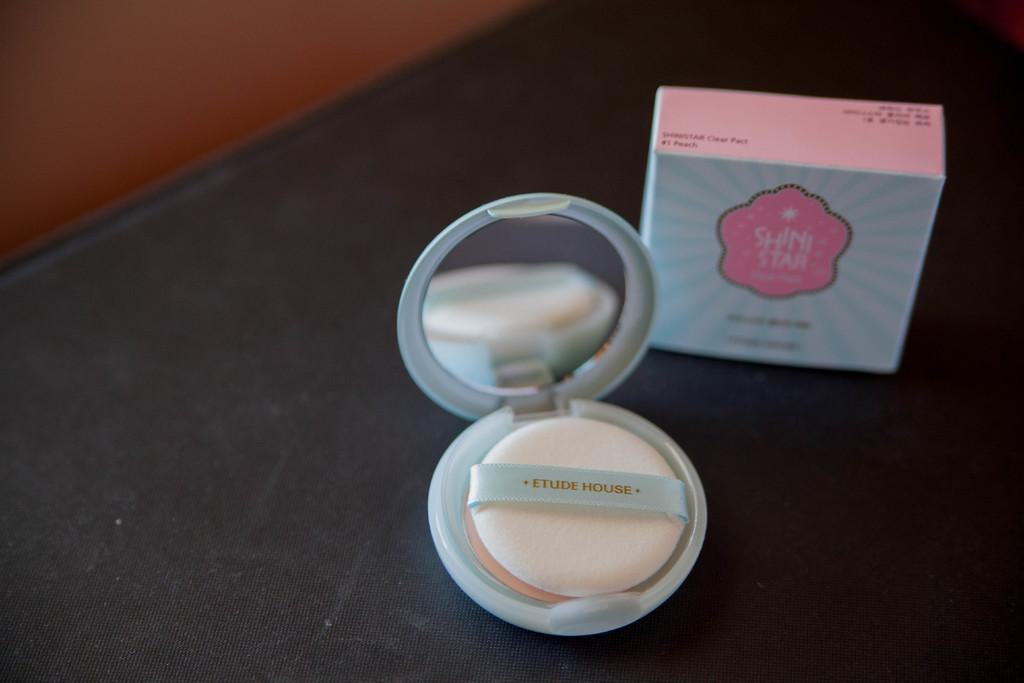<image>
Provide a brief description of the given image. A round and opened open Etude House makeup case with a small mirror inside is on a dark table. 